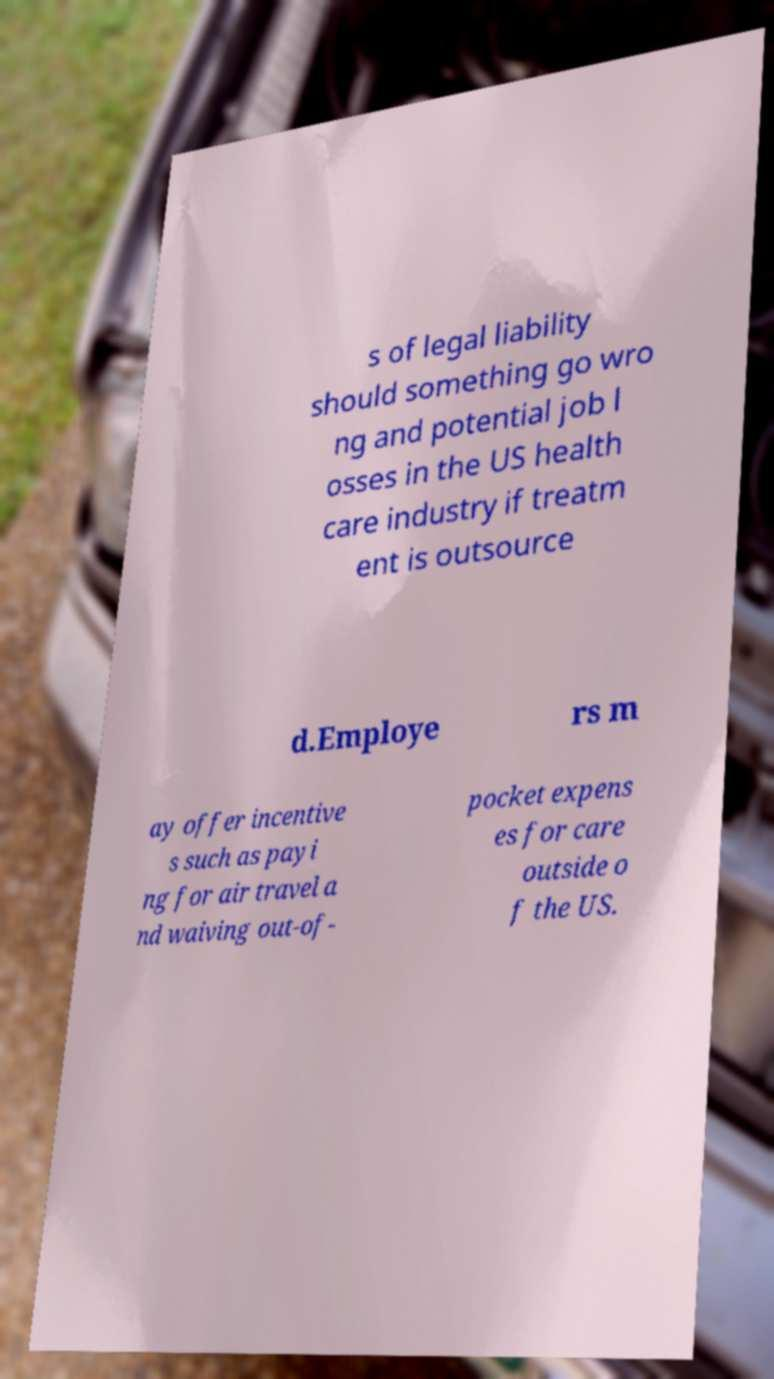What messages or text are displayed in this image? I need them in a readable, typed format. s of legal liability should something go wro ng and potential job l osses in the US health care industry if treatm ent is outsource d.Employe rs m ay offer incentive s such as payi ng for air travel a nd waiving out-of- pocket expens es for care outside o f the US. 